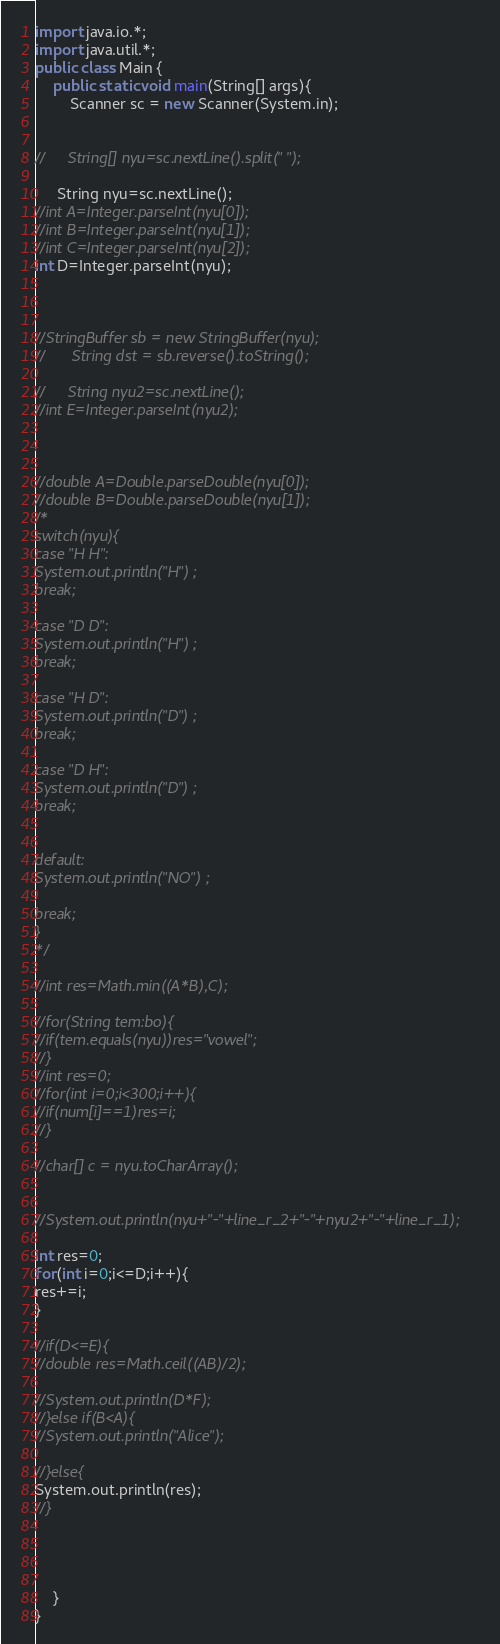<code> <loc_0><loc_0><loc_500><loc_500><_Java_>import java.io.*;
import java.util.*;
public class Main {
	public static void main(String[] args){
		Scanner sc = new Scanner(System.in);
 

//     String[] nyu=sc.nextLine().split(" ");

     String nyu=sc.nextLine();
//int A=Integer.parseInt(nyu[0]);
//int B=Integer.parseInt(nyu[1]);
//int C=Integer.parseInt(nyu[2]);
int D=Integer.parseInt(nyu);



//StringBuffer sb = new StringBuffer(nyu);
//		String dst = sb.reverse().toString();

//     String nyu2=sc.nextLine();
//int E=Integer.parseInt(nyu2);



//double A=Double.parseDouble(nyu[0]);
//double B=Double.parseDouble(nyu[1]);
/*
switch(nyu){
case "H H":
System.out.println("H") ;
break;

case "D D":
System.out.println("H") ;
break;

case "H D":
System.out.println("D") ;
break;

case "D H":
System.out.println("D") ;
break;


default:
System.out.println("NO") ;

break;
}
*/

//int res=Math.min((A*B),C);

//for(String tem:bo){
//if(tem.equals(nyu))res="vowel";
//}
//int res=0;
//for(int i=0;i<300;i++){
//if(num[i]==1)res=i;
//}

//char[] c = nyu.toCharArray();


//System.out.println(nyu+"-"+line_r_2+"-"+nyu2+"-"+line_r_1);

int res=0;
for(int i=0;i<=D;i++){
res+=i;
}

//if(D<=E){
//double res=Math.ceil((AB)/2);

//System.out.println(D*F);
//}else if(B<A){
//System.out.println("Alice");

//}else{
System.out.println(res);
//}




	}
}</code> 